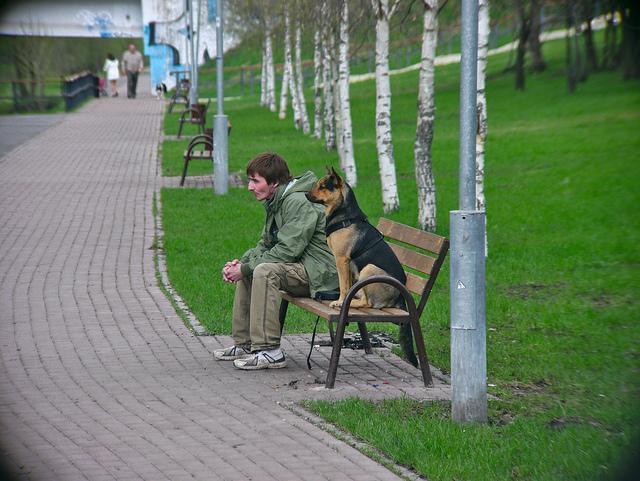What is the black strap hanging from the bench called?
Select the correct answer and articulate reasoning with the following format: 'Answer: answer
Rationale: rationale.'
Options: Collar, necklace, whip, leash. Answer: leash.
Rationale: The black strap is the dog's leash. 